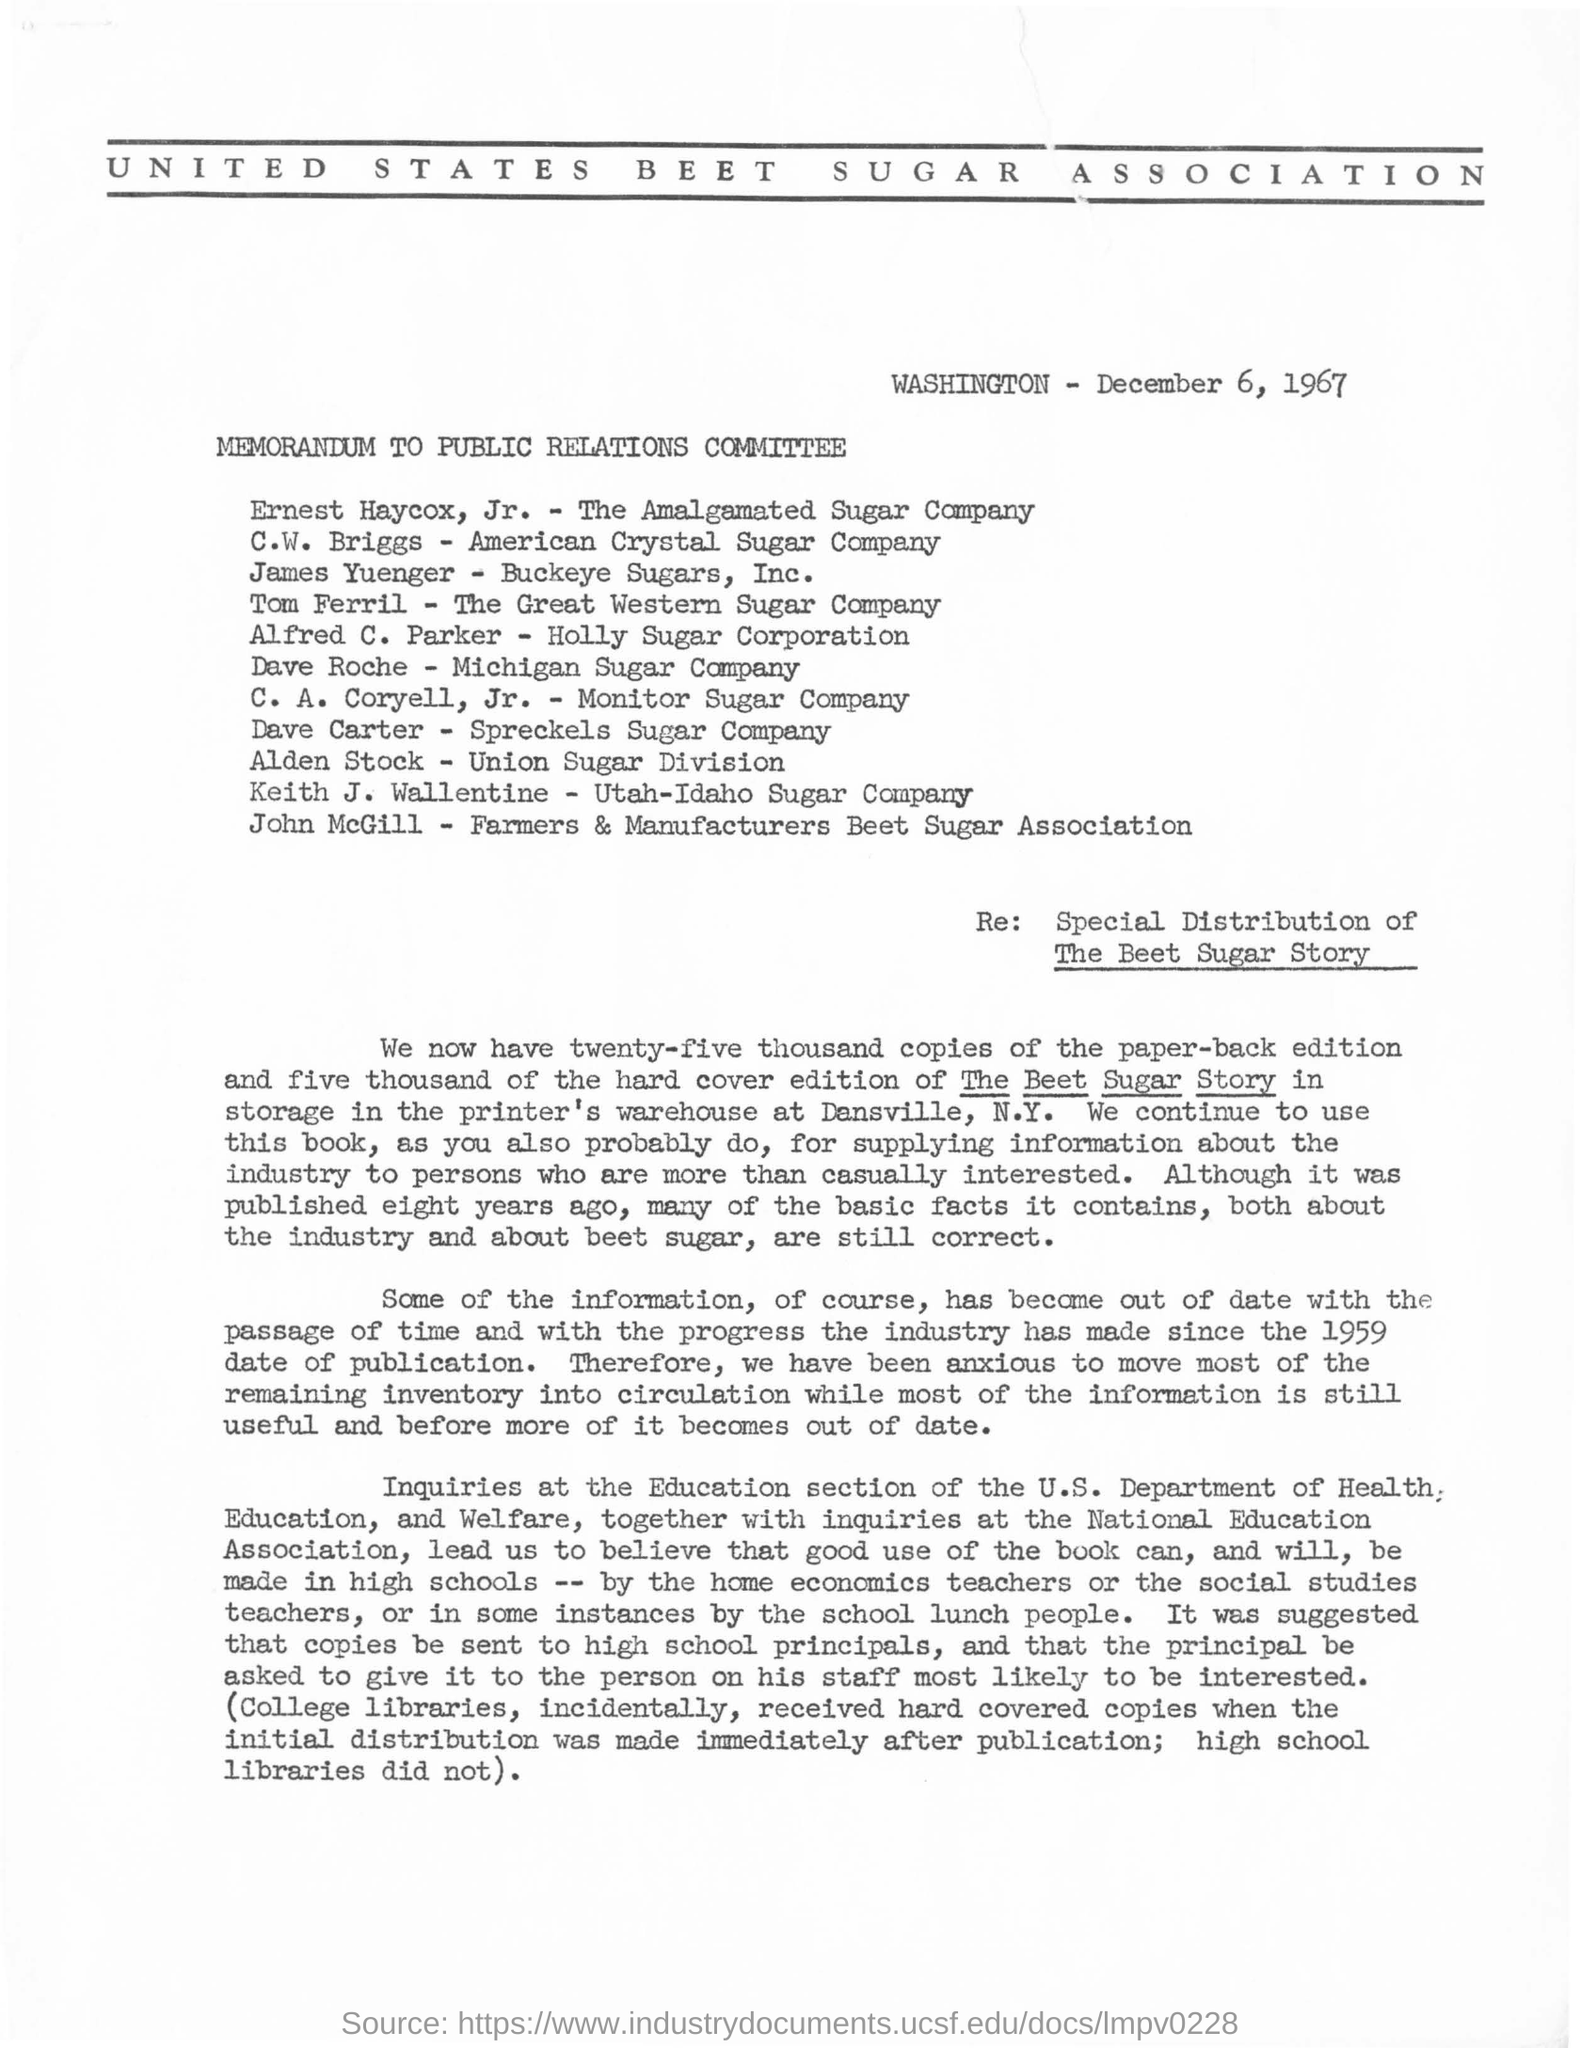Indicate a few pertinent items in this graphic. The United States Beet Sugar Association is the name of the association mentioned. The date mentioned in the given page is December 6, 1967. The Amalgamated Sugar Company is the company to which Ernest Haycox belongs. C.W. Briggs is a member of the American Crystal Sugar Company. Dave Roche belongs to the Michigan Sugar Company. 